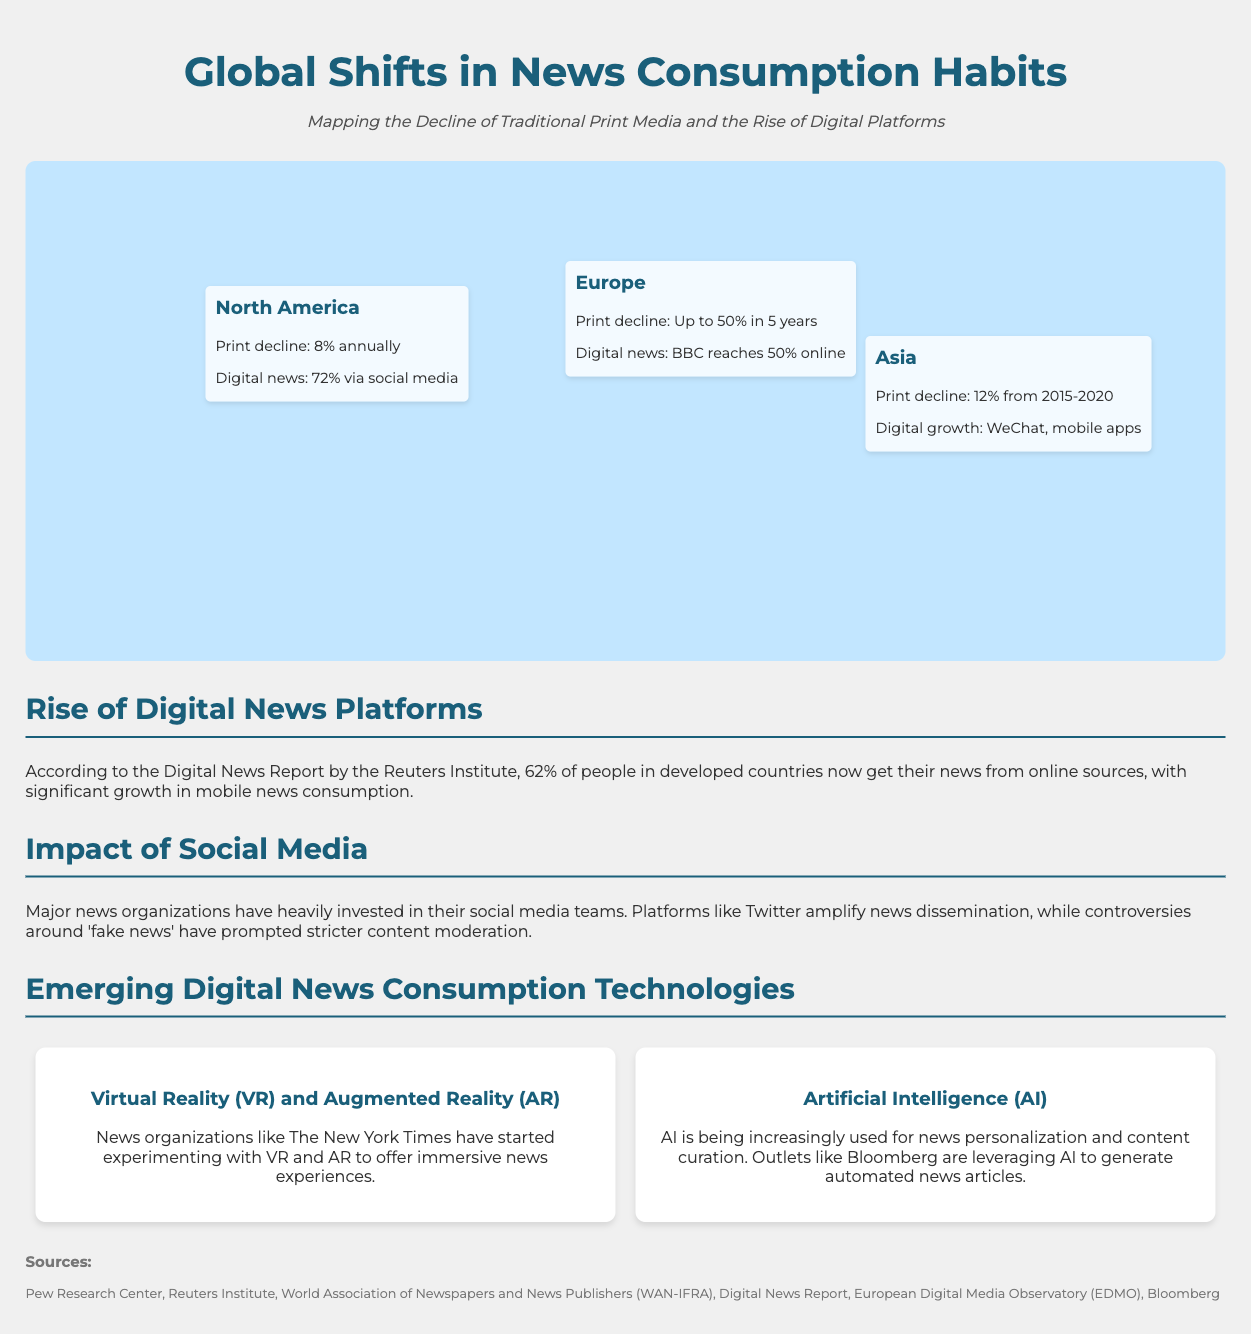What is the print decline rate in North America? The print decline rate in North America is stated as 8% annually.
Answer: 8% annually What percentage of digital news consumption in North America is through social media? The document mentions that 72% of digital news in North America comes via social media.
Answer: 72% What is the print decline percentage in Europe over the next five years? The infographic indicates that print decline in Europe is up to 50% in 5 years.
Answer: Up to 50% What percentage of people in developed countries get their news from online sources? According to the Digital News Report, 62% of people in developed countries now get their news from online sources.
Answer: 62% Which technologies are mentioned for emerging digital news consumption? The document specifies Virtual Reality (VR), Augmented Reality (AR), and Artificial Intelligence (AI) as emerging technologies.
Answer: VR, AR, AI What is the main social media platform highlighted in the document as influencing news dissemination? The document specifically mentions Twitter as a platform that amplifies news dissemination.
Answer: Twitter Which organization has started using VR and AR for news experiences? The New York Times is noted for experimenting with VR and AR for immersive news experiences.
Answer: The New York Times What major issue has prompted stricter content moderation in news? The document indicates that controversies around 'fake news' have led to stricter content moderation.
Answer: 'Fake news' What percentage of digital news does BBC reach online in Europe? The infographic states that BBC reaches 50% online in Europe.
Answer: 50% 